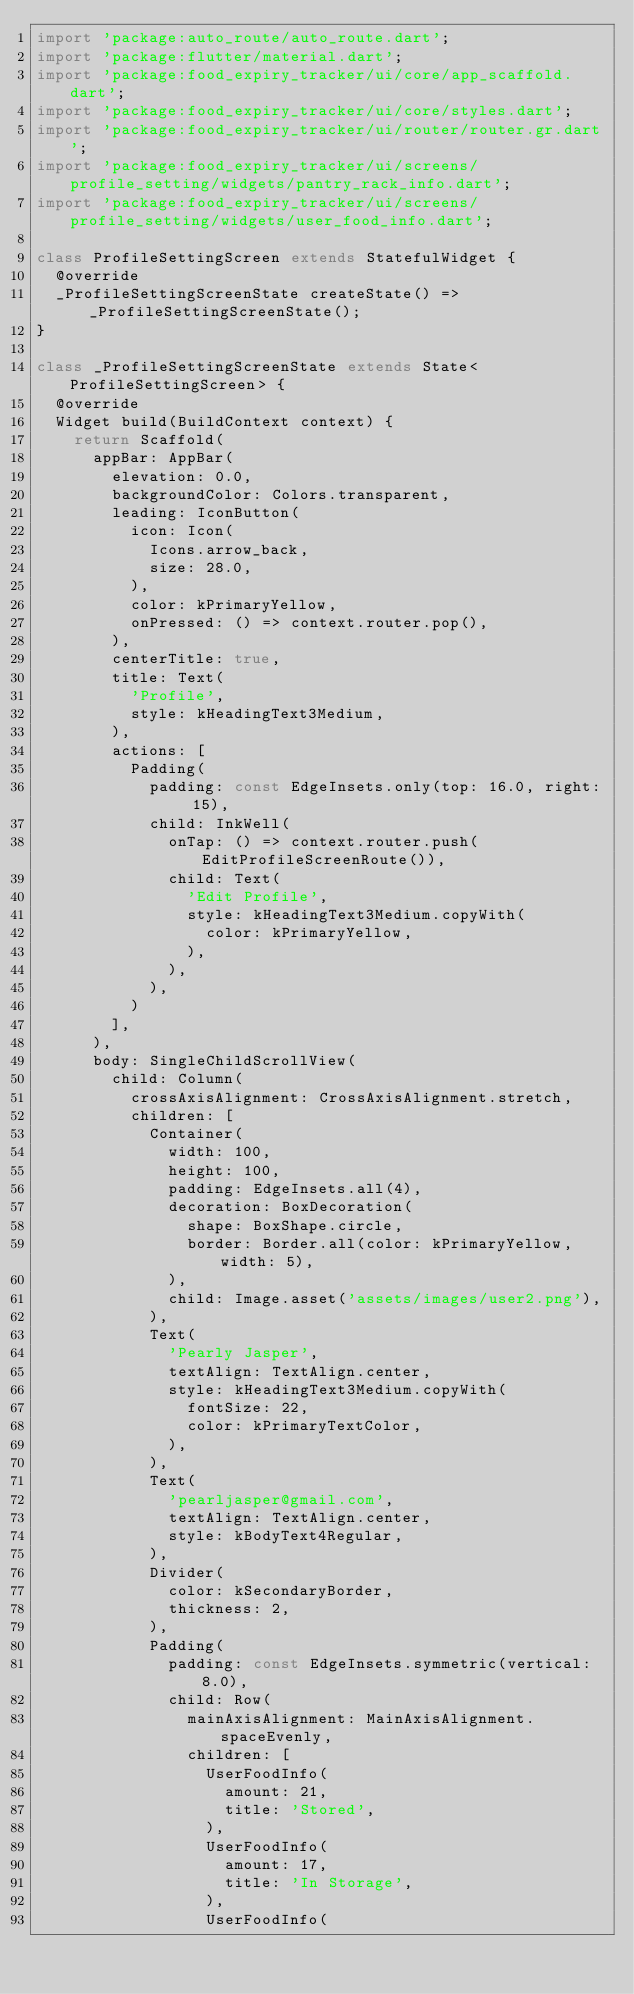Convert code to text. <code><loc_0><loc_0><loc_500><loc_500><_Dart_>import 'package:auto_route/auto_route.dart';
import 'package:flutter/material.dart';
import 'package:food_expiry_tracker/ui/core/app_scaffold.dart';
import 'package:food_expiry_tracker/ui/core/styles.dart';
import 'package:food_expiry_tracker/ui/router/router.gr.dart';
import 'package:food_expiry_tracker/ui/screens/profile_setting/widgets/pantry_rack_info.dart';
import 'package:food_expiry_tracker/ui/screens/profile_setting/widgets/user_food_info.dart';

class ProfileSettingScreen extends StatefulWidget {
  @override
  _ProfileSettingScreenState createState() => _ProfileSettingScreenState();
}

class _ProfileSettingScreenState extends State<ProfileSettingScreen> {
  @override
  Widget build(BuildContext context) {
    return Scaffold(
      appBar: AppBar(
        elevation: 0.0,
        backgroundColor: Colors.transparent,
        leading: IconButton(
          icon: Icon(
            Icons.arrow_back,
            size: 28.0,
          ),
          color: kPrimaryYellow,
          onPressed: () => context.router.pop(),
        ),
        centerTitle: true,
        title: Text(
          'Profile',
          style: kHeadingText3Medium,
        ),
        actions: [
          Padding(
            padding: const EdgeInsets.only(top: 16.0, right: 15),
            child: InkWell(
              onTap: () => context.router.push(EditProfileScreenRoute()),
              child: Text(
                'Edit Profile',
                style: kHeadingText3Medium.copyWith(
                  color: kPrimaryYellow,
                ),
              ),
            ),
          )
        ],
      ),
      body: SingleChildScrollView(
        child: Column(
          crossAxisAlignment: CrossAxisAlignment.stretch,
          children: [
            Container(
              width: 100,
              height: 100,
              padding: EdgeInsets.all(4),
              decoration: BoxDecoration(
                shape: BoxShape.circle,
                border: Border.all(color: kPrimaryYellow, width: 5),
              ),
              child: Image.asset('assets/images/user2.png'),
            ),
            Text(
              'Pearly Jasper',
              textAlign: TextAlign.center,
              style: kHeadingText3Medium.copyWith(
                fontSize: 22,
                color: kPrimaryTextColor,
              ),
            ),
            Text(
              'pearljasper@gmail.com',
              textAlign: TextAlign.center,
              style: kBodyText4Regular,
            ),
            Divider(
              color: kSecondaryBorder,
              thickness: 2,
            ),
            Padding(
              padding: const EdgeInsets.symmetric(vertical: 8.0),
              child: Row(
                mainAxisAlignment: MainAxisAlignment.spaceEvenly,
                children: [
                  UserFoodInfo(
                    amount: 21,
                    title: 'Stored',
                  ),
                  UserFoodInfo(
                    amount: 17,
                    title: 'In Storage',
                  ),
                  UserFoodInfo(</code> 